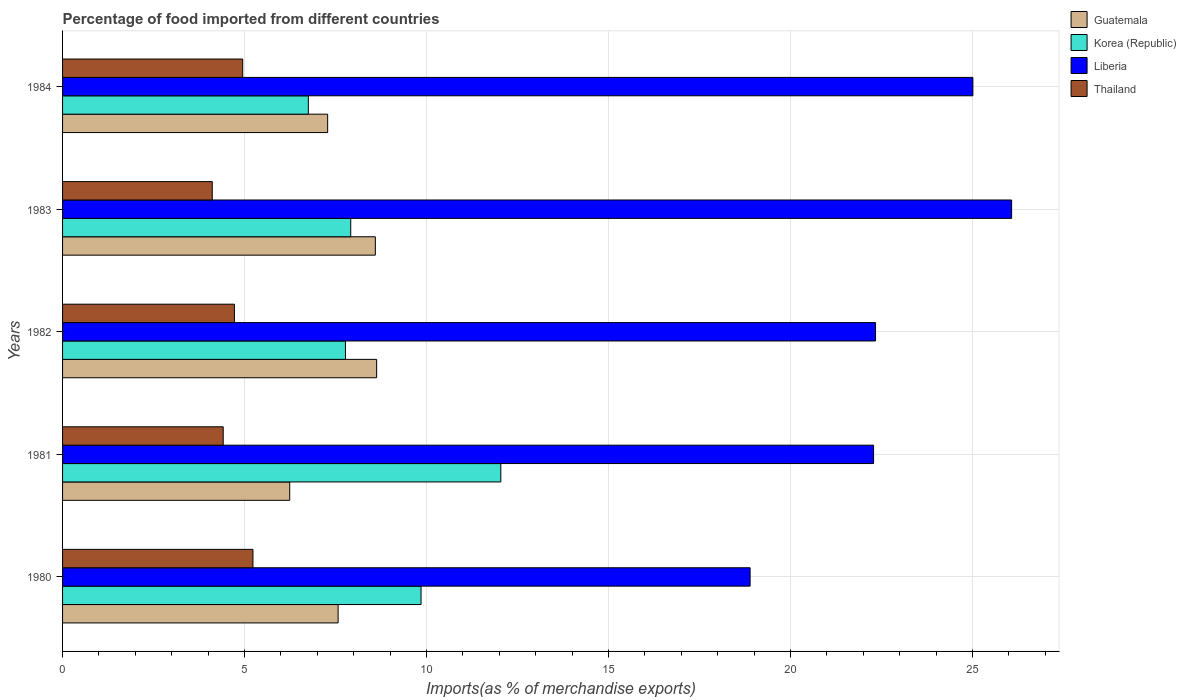How many different coloured bars are there?
Your answer should be compact. 4. Are the number of bars per tick equal to the number of legend labels?
Make the answer very short. Yes. Are the number of bars on each tick of the Y-axis equal?
Provide a succinct answer. Yes. In how many cases, is the number of bars for a given year not equal to the number of legend labels?
Your answer should be very brief. 0. What is the percentage of imports to different countries in Korea (Republic) in 1982?
Your answer should be very brief. 7.77. Across all years, what is the maximum percentage of imports to different countries in Guatemala?
Provide a succinct answer. 8.63. Across all years, what is the minimum percentage of imports to different countries in Guatemala?
Offer a very short reply. 6.24. In which year was the percentage of imports to different countries in Guatemala maximum?
Offer a terse response. 1982. In which year was the percentage of imports to different countries in Liberia minimum?
Give a very brief answer. 1980. What is the total percentage of imports to different countries in Korea (Republic) in the graph?
Keep it short and to the point. 44.33. What is the difference between the percentage of imports to different countries in Thailand in 1980 and that in 1984?
Your response must be concise. 0.28. What is the difference between the percentage of imports to different countries in Liberia in 1980 and the percentage of imports to different countries in Korea (Republic) in 1982?
Ensure brevity in your answer.  11.12. What is the average percentage of imports to different countries in Korea (Republic) per year?
Offer a terse response. 8.87. In the year 1981, what is the difference between the percentage of imports to different countries in Guatemala and percentage of imports to different countries in Liberia?
Your response must be concise. -16.04. In how many years, is the percentage of imports to different countries in Liberia greater than 11 %?
Offer a very short reply. 5. What is the ratio of the percentage of imports to different countries in Korea (Republic) in 1981 to that in 1983?
Provide a short and direct response. 1.52. Is the difference between the percentage of imports to different countries in Guatemala in 1983 and 1984 greater than the difference between the percentage of imports to different countries in Liberia in 1983 and 1984?
Give a very brief answer. Yes. What is the difference between the highest and the second highest percentage of imports to different countries in Guatemala?
Provide a succinct answer. 0.04. What is the difference between the highest and the lowest percentage of imports to different countries in Korea (Republic)?
Give a very brief answer. 5.29. In how many years, is the percentage of imports to different countries in Guatemala greater than the average percentage of imports to different countries in Guatemala taken over all years?
Your answer should be compact. 2. Is the sum of the percentage of imports to different countries in Liberia in 1980 and 1983 greater than the maximum percentage of imports to different countries in Thailand across all years?
Make the answer very short. Yes. What does the 4th bar from the top in 1980 represents?
Offer a terse response. Guatemala. What does the 2nd bar from the bottom in 1981 represents?
Your answer should be compact. Korea (Republic). Is it the case that in every year, the sum of the percentage of imports to different countries in Korea (Republic) and percentage of imports to different countries in Guatemala is greater than the percentage of imports to different countries in Liberia?
Provide a succinct answer. No. How many bars are there?
Ensure brevity in your answer.  20. How many years are there in the graph?
Provide a short and direct response. 5. Does the graph contain any zero values?
Provide a succinct answer. No. Does the graph contain grids?
Offer a very short reply. Yes. How many legend labels are there?
Provide a short and direct response. 4. What is the title of the graph?
Ensure brevity in your answer.  Percentage of food imported from different countries. What is the label or title of the X-axis?
Keep it short and to the point. Imports(as % of merchandise exports). What is the Imports(as % of merchandise exports) in Guatemala in 1980?
Provide a succinct answer. 7.57. What is the Imports(as % of merchandise exports) of Korea (Republic) in 1980?
Give a very brief answer. 9.85. What is the Imports(as % of merchandise exports) of Liberia in 1980?
Offer a very short reply. 18.89. What is the Imports(as % of merchandise exports) in Thailand in 1980?
Your response must be concise. 5.23. What is the Imports(as % of merchandise exports) of Guatemala in 1981?
Provide a succinct answer. 6.24. What is the Imports(as % of merchandise exports) in Korea (Republic) in 1981?
Offer a very short reply. 12.04. What is the Imports(as % of merchandise exports) of Liberia in 1981?
Make the answer very short. 22.28. What is the Imports(as % of merchandise exports) in Thailand in 1981?
Offer a terse response. 4.41. What is the Imports(as % of merchandise exports) in Guatemala in 1982?
Make the answer very short. 8.63. What is the Imports(as % of merchandise exports) in Korea (Republic) in 1982?
Provide a short and direct response. 7.77. What is the Imports(as % of merchandise exports) of Liberia in 1982?
Ensure brevity in your answer.  22.34. What is the Imports(as % of merchandise exports) of Thailand in 1982?
Provide a succinct answer. 4.72. What is the Imports(as % of merchandise exports) of Guatemala in 1983?
Provide a succinct answer. 8.59. What is the Imports(as % of merchandise exports) of Korea (Republic) in 1983?
Your answer should be compact. 7.92. What is the Imports(as % of merchandise exports) of Liberia in 1983?
Your answer should be compact. 26.08. What is the Imports(as % of merchandise exports) in Thailand in 1983?
Provide a succinct answer. 4.11. What is the Imports(as % of merchandise exports) of Guatemala in 1984?
Ensure brevity in your answer.  7.28. What is the Imports(as % of merchandise exports) in Korea (Republic) in 1984?
Give a very brief answer. 6.75. What is the Imports(as % of merchandise exports) in Liberia in 1984?
Give a very brief answer. 25.01. What is the Imports(as % of merchandise exports) of Thailand in 1984?
Your answer should be compact. 4.95. Across all years, what is the maximum Imports(as % of merchandise exports) of Guatemala?
Your answer should be compact. 8.63. Across all years, what is the maximum Imports(as % of merchandise exports) in Korea (Republic)?
Provide a succinct answer. 12.04. Across all years, what is the maximum Imports(as % of merchandise exports) in Liberia?
Give a very brief answer. 26.08. Across all years, what is the maximum Imports(as % of merchandise exports) in Thailand?
Give a very brief answer. 5.23. Across all years, what is the minimum Imports(as % of merchandise exports) in Guatemala?
Your response must be concise. 6.24. Across all years, what is the minimum Imports(as % of merchandise exports) in Korea (Republic)?
Your answer should be compact. 6.75. Across all years, what is the minimum Imports(as % of merchandise exports) of Liberia?
Ensure brevity in your answer.  18.89. Across all years, what is the minimum Imports(as % of merchandise exports) in Thailand?
Your answer should be very brief. 4.11. What is the total Imports(as % of merchandise exports) of Guatemala in the graph?
Give a very brief answer. 38.32. What is the total Imports(as % of merchandise exports) of Korea (Republic) in the graph?
Keep it short and to the point. 44.33. What is the total Imports(as % of merchandise exports) of Liberia in the graph?
Keep it short and to the point. 114.6. What is the total Imports(as % of merchandise exports) of Thailand in the graph?
Give a very brief answer. 23.43. What is the difference between the Imports(as % of merchandise exports) of Guatemala in 1980 and that in 1981?
Provide a succinct answer. 1.33. What is the difference between the Imports(as % of merchandise exports) of Korea (Republic) in 1980 and that in 1981?
Provide a short and direct response. -2.19. What is the difference between the Imports(as % of merchandise exports) of Liberia in 1980 and that in 1981?
Offer a terse response. -3.39. What is the difference between the Imports(as % of merchandise exports) in Thailand in 1980 and that in 1981?
Your response must be concise. 0.82. What is the difference between the Imports(as % of merchandise exports) in Guatemala in 1980 and that in 1982?
Offer a very short reply. -1.06. What is the difference between the Imports(as % of merchandise exports) of Korea (Republic) in 1980 and that in 1982?
Offer a terse response. 2.08. What is the difference between the Imports(as % of merchandise exports) of Liberia in 1980 and that in 1982?
Provide a short and direct response. -3.45. What is the difference between the Imports(as % of merchandise exports) in Thailand in 1980 and that in 1982?
Ensure brevity in your answer.  0.51. What is the difference between the Imports(as % of merchandise exports) in Guatemala in 1980 and that in 1983?
Your response must be concise. -1.02. What is the difference between the Imports(as % of merchandise exports) of Korea (Republic) in 1980 and that in 1983?
Your answer should be very brief. 1.93. What is the difference between the Imports(as % of merchandise exports) in Liberia in 1980 and that in 1983?
Make the answer very short. -7.19. What is the difference between the Imports(as % of merchandise exports) of Thailand in 1980 and that in 1983?
Your answer should be compact. 1.12. What is the difference between the Imports(as % of merchandise exports) of Guatemala in 1980 and that in 1984?
Keep it short and to the point. 0.29. What is the difference between the Imports(as % of merchandise exports) in Korea (Republic) in 1980 and that in 1984?
Provide a succinct answer. 3.1. What is the difference between the Imports(as % of merchandise exports) in Liberia in 1980 and that in 1984?
Offer a terse response. -6.12. What is the difference between the Imports(as % of merchandise exports) in Thailand in 1980 and that in 1984?
Keep it short and to the point. 0.28. What is the difference between the Imports(as % of merchandise exports) in Guatemala in 1981 and that in 1982?
Your answer should be very brief. -2.39. What is the difference between the Imports(as % of merchandise exports) in Korea (Republic) in 1981 and that in 1982?
Your answer should be compact. 4.27. What is the difference between the Imports(as % of merchandise exports) in Liberia in 1981 and that in 1982?
Provide a short and direct response. -0.05. What is the difference between the Imports(as % of merchandise exports) in Thailand in 1981 and that in 1982?
Provide a succinct answer. -0.31. What is the difference between the Imports(as % of merchandise exports) in Guatemala in 1981 and that in 1983?
Keep it short and to the point. -2.35. What is the difference between the Imports(as % of merchandise exports) of Korea (Republic) in 1981 and that in 1983?
Keep it short and to the point. 4.12. What is the difference between the Imports(as % of merchandise exports) in Liberia in 1981 and that in 1983?
Provide a short and direct response. -3.79. What is the difference between the Imports(as % of merchandise exports) in Thailand in 1981 and that in 1983?
Your response must be concise. 0.3. What is the difference between the Imports(as % of merchandise exports) in Guatemala in 1981 and that in 1984?
Ensure brevity in your answer.  -1.04. What is the difference between the Imports(as % of merchandise exports) in Korea (Republic) in 1981 and that in 1984?
Your response must be concise. 5.29. What is the difference between the Imports(as % of merchandise exports) of Liberia in 1981 and that in 1984?
Your answer should be compact. -2.73. What is the difference between the Imports(as % of merchandise exports) of Thailand in 1981 and that in 1984?
Give a very brief answer. -0.54. What is the difference between the Imports(as % of merchandise exports) in Guatemala in 1982 and that in 1983?
Make the answer very short. 0.04. What is the difference between the Imports(as % of merchandise exports) of Korea (Republic) in 1982 and that in 1983?
Keep it short and to the point. -0.15. What is the difference between the Imports(as % of merchandise exports) of Liberia in 1982 and that in 1983?
Offer a terse response. -3.74. What is the difference between the Imports(as % of merchandise exports) of Thailand in 1982 and that in 1983?
Provide a succinct answer. 0.61. What is the difference between the Imports(as % of merchandise exports) in Guatemala in 1982 and that in 1984?
Make the answer very short. 1.35. What is the difference between the Imports(as % of merchandise exports) of Korea (Republic) in 1982 and that in 1984?
Your answer should be very brief. 1.02. What is the difference between the Imports(as % of merchandise exports) in Liberia in 1982 and that in 1984?
Make the answer very short. -2.68. What is the difference between the Imports(as % of merchandise exports) of Thailand in 1982 and that in 1984?
Provide a short and direct response. -0.23. What is the difference between the Imports(as % of merchandise exports) in Guatemala in 1983 and that in 1984?
Your answer should be very brief. 1.31. What is the difference between the Imports(as % of merchandise exports) in Korea (Republic) in 1983 and that in 1984?
Your answer should be compact. 1.17. What is the difference between the Imports(as % of merchandise exports) in Liberia in 1983 and that in 1984?
Offer a terse response. 1.06. What is the difference between the Imports(as % of merchandise exports) of Thailand in 1983 and that in 1984?
Provide a short and direct response. -0.84. What is the difference between the Imports(as % of merchandise exports) in Guatemala in 1980 and the Imports(as % of merchandise exports) in Korea (Republic) in 1981?
Provide a short and direct response. -4.47. What is the difference between the Imports(as % of merchandise exports) of Guatemala in 1980 and the Imports(as % of merchandise exports) of Liberia in 1981?
Offer a terse response. -14.71. What is the difference between the Imports(as % of merchandise exports) of Guatemala in 1980 and the Imports(as % of merchandise exports) of Thailand in 1981?
Offer a very short reply. 3.16. What is the difference between the Imports(as % of merchandise exports) of Korea (Republic) in 1980 and the Imports(as % of merchandise exports) of Liberia in 1981?
Offer a very short reply. -12.43. What is the difference between the Imports(as % of merchandise exports) in Korea (Republic) in 1980 and the Imports(as % of merchandise exports) in Thailand in 1981?
Offer a terse response. 5.44. What is the difference between the Imports(as % of merchandise exports) in Liberia in 1980 and the Imports(as % of merchandise exports) in Thailand in 1981?
Your response must be concise. 14.48. What is the difference between the Imports(as % of merchandise exports) in Guatemala in 1980 and the Imports(as % of merchandise exports) in Korea (Republic) in 1982?
Keep it short and to the point. -0.2. What is the difference between the Imports(as % of merchandise exports) of Guatemala in 1980 and the Imports(as % of merchandise exports) of Liberia in 1982?
Keep it short and to the point. -14.77. What is the difference between the Imports(as % of merchandise exports) in Guatemala in 1980 and the Imports(as % of merchandise exports) in Thailand in 1982?
Provide a succinct answer. 2.85. What is the difference between the Imports(as % of merchandise exports) of Korea (Republic) in 1980 and the Imports(as % of merchandise exports) of Liberia in 1982?
Your answer should be very brief. -12.49. What is the difference between the Imports(as % of merchandise exports) in Korea (Republic) in 1980 and the Imports(as % of merchandise exports) in Thailand in 1982?
Offer a very short reply. 5.13. What is the difference between the Imports(as % of merchandise exports) of Liberia in 1980 and the Imports(as % of merchandise exports) of Thailand in 1982?
Provide a succinct answer. 14.17. What is the difference between the Imports(as % of merchandise exports) in Guatemala in 1980 and the Imports(as % of merchandise exports) in Korea (Republic) in 1983?
Your response must be concise. -0.35. What is the difference between the Imports(as % of merchandise exports) of Guatemala in 1980 and the Imports(as % of merchandise exports) of Liberia in 1983?
Offer a very short reply. -18.5. What is the difference between the Imports(as % of merchandise exports) of Guatemala in 1980 and the Imports(as % of merchandise exports) of Thailand in 1983?
Provide a short and direct response. 3.46. What is the difference between the Imports(as % of merchandise exports) in Korea (Republic) in 1980 and the Imports(as % of merchandise exports) in Liberia in 1983?
Give a very brief answer. -16.23. What is the difference between the Imports(as % of merchandise exports) in Korea (Republic) in 1980 and the Imports(as % of merchandise exports) in Thailand in 1983?
Keep it short and to the point. 5.74. What is the difference between the Imports(as % of merchandise exports) in Liberia in 1980 and the Imports(as % of merchandise exports) in Thailand in 1983?
Offer a terse response. 14.78. What is the difference between the Imports(as % of merchandise exports) in Guatemala in 1980 and the Imports(as % of merchandise exports) in Korea (Republic) in 1984?
Make the answer very short. 0.82. What is the difference between the Imports(as % of merchandise exports) of Guatemala in 1980 and the Imports(as % of merchandise exports) of Liberia in 1984?
Your response must be concise. -17.44. What is the difference between the Imports(as % of merchandise exports) in Guatemala in 1980 and the Imports(as % of merchandise exports) in Thailand in 1984?
Make the answer very short. 2.62. What is the difference between the Imports(as % of merchandise exports) of Korea (Republic) in 1980 and the Imports(as % of merchandise exports) of Liberia in 1984?
Offer a terse response. -15.16. What is the difference between the Imports(as % of merchandise exports) of Korea (Republic) in 1980 and the Imports(as % of merchandise exports) of Thailand in 1984?
Your answer should be compact. 4.9. What is the difference between the Imports(as % of merchandise exports) in Liberia in 1980 and the Imports(as % of merchandise exports) in Thailand in 1984?
Offer a terse response. 13.94. What is the difference between the Imports(as % of merchandise exports) in Guatemala in 1981 and the Imports(as % of merchandise exports) in Korea (Republic) in 1982?
Give a very brief answer. -1.53. What is the difference between the Imports(as % of merchandise exports) in Guatemala in 1981 and the Imports(as % of merchandise exports) in Liberia in 1982?
Your response must be concise. -16.1. What is the difference between the Imports(as % of merchandise exports) of Guatemala in 1981 and the Imports(as % of merchandise exports) of Thailand in 1982?
Ensure brevity in your answer.  1.52. What is the difference between the Imports(as % of merchandise exports) of Korea (Republic) in 1981 and the Imports(as % of merchandise exports) of Liberia in 1982?
Ensure brevity in your answer.  -10.3. What is the difference between the Imports(as % of merchandise exports) of Korea (Republic) in 1981 and the Imports(as % of merchandise exports) of Thailand in 1982?
Your answer should be very brief. 7.32. What is the difference between the Imports(as % of merchandise exports) in Liberia in 1981 and the Imports(as % of merchandise exports) in Thailand in 1982?
Keep it short and to the point. 17.56. What is the difference between the Imports(as % of merchandise exports) in Guatemala in 1981 and the Imports(as % of merchandise exports) in Korea (Republic) in 1983?
Provide a succinct answer. -1.68. What is the difference between the Imports(as % of merchandise exports) of Guatemala in 1981 and the Imports(as % of merchandise exports) of Liberia in 1983?
Your answer should be very brief. -19.83. What is the difference between the Imports(as % of merchandise exports) of Guatemala in 1981 and the Imports(as % of merchandise exports) of Thailand in 1983?
Keep it short and to the point. 2.13. What is the difference between the Imports(as % of merchandise exports) in Korea (Republic) in 1981 and the Imports(as % of merchandise exports) in Liberia in 1983?
Your answer should be compact. -14.03. What is the difference between the Imports(as % of merchandise exports) in Korea (Republic) in 1981 and the Imports(as % of merchandise exports) in Thailand in 1983?
Your answer should be very brief. 7.93. What is the difference between the Imports(as % of merchandise exports) of Liberia in 1981 and the Imports(as % of merchandise exports) of Thailand in 1983?
Ensure brevity in your answer.  18.17. What is the difference between the Imports(as % of merchandise exports) in Guatemala in 1981 and the Imports(as % of merchandise exports) in Korea (Republic) in 1984?
Make the answer very short. -0.51. What is the difference between the Imports(as % of merchandise exports) of Guatemala in 1981 and the Imports(as % of merchandise exports) of Liberia in 1984?
Provide a short and direct response. -18.77. What is the difference between the Imports(as % of merchandise exports) of Guatemala in 1981 and the Imports(as % of merchandise exports) of Thailand in 1984?
Keep it short and to the point. 1.29. What is the difference between the Imports(as % of merchandise exports) of Korea (Republic) in 1981 and the Imports(as % of merchandise exports) of Liberia in 1984?
Ensure brevity in your answer.  -12.97. What is the difference between the Imports(as % of merchandise exports) in Korea (Republic) in 1981 and the Imports(as % of merchandise exports) in Thailand in 1984?
Your answer should be very brief. 7.09. What is the difference between the Imports(as % of merchandise exports) in Liberia in 1981 and the Imports(as % of merchandise exports) in Thailand in 1984?
Keep it short and to the point. 17.33. What is the difference between the Imports(as % of merchandise exports) in Guatemala in 1982 and the Imports(as % of merchandise exports) in Korea (Republic) in 1983?
Provide a succinct answer. 0.71. What is the difference between the Imports(as % of merchandise exports) in Guatemala in 1982 and the Imports(as % of merchandise exports) in Liberia in 1983?
Ensure brevity in your answer.  -17.45. What is the difference between the Imports(as % of merchandise exports) of Guatemala in 1982 and the Imports(as % of merchandise exports) of Thailand in 1983?
Provide a short and direct response. 4.52. What is the difference between the Imports(as % of merchandise exports) in Korea (Republic) in 1982 and the Imports(as % of merchandise exports) in Liberia in 1983?
Make the answer very short. -18.3. What is the difference between the Imports(as % of merchandise exports) of Korea (Republic) in 1982 and the Imports(as % of merchandise exports) of Thailand in 1983?
Offer a very short reply. 3.66. What is the difference between the Imports(as % of merchandise exports) of Liberia in 1982 and the Imports(as % of merchandise exports) of Thailand in 1983?
Your response must be concise. 18.22. What is the difference between the Imports(as % of merchandise exports) of Guatemala in 1982 and the Imports(as % of merchandise exports) of Korea (Republic) in 1984?
Provide a short and direct response. 1.88. What is the difference between the Imports(as % of merchandise exports) of Guatemala in 1982 and the Imports(as % of merchandise exports) of Liberia in 1984?
Provide a short and direct response. -16.38. What is the difference between the Imports(as % of merchandise exports) in Guatemala in 1982 and the Imports(as % of merchandise exports) in Thailand in 1984?
Your response must be concise. 3.68. What is the difference between the Imports(as % of merchandise exports) of Korea (Republic) in 1982 and the Imports(as % of merchandise exports) of Liberia in 1984?
Provide a succinct answer. -17.24. What is the difference between the Imports(as % of merchandise exports) in Korea (Republic) in 1982 and the Imports(as % of merchandise exports) in Thailand in 1984?
Keep it short and to the point. 2.82. What is the difference between the Imports(as % of merchandise exports) in Liberia in 1982 and the Imports(as % of merchandise exports) in Thailand in 1984?
Your answer should be compact. 17.39. What is the difference between the Imports(as % of merchandise exports) in Guatemala in 1983 and the Imports(as % of merchandise exports) in Korea (Republic) in 1984?
Provide a short and direct response. 1.84. What is the difference between the Imports(as % of merchandise exports) of Guatemala in 1983 and the Imports(as % of merchandise exports) of Liberia in 1984?
Offer a very short reply. -16.42. What is the difference between the Imports(as % of merchandise exports) in Guatemala in 1983 and the Imports(as % of merchandise exports) in Thailand in 1984?
Provide a short and direct response. 3.64. What is the difference between the Imports(as % of merchandise exports) of Korea (Republic) in 1983 and the Imports(as % of merchandise exports) of Liberia in 1984?
Provide a succinct answer. -17.09. What is the difference between the Imports(as % of merchandise exports) of Korea (Republic) in 1983 and the Imports(as % of merchandise exports) of Thailand in 1984?
Your response must be concise. 2.97. What is the difference between the Imports(as % of merchandise exports) in Liberia in 1983 and the Imports(as % of merchandise exports) in Thailand in 1984?
Keep it short and to the point. 21.13. What is the average Imports(as % of merchandise exports) of Guatemala per year?
Make the answer very short. 7.66. What is the average Imports(as % of merchandise exports) of Korea (Republic) per year?
Offer a very short reply. 8.87. What is the average Imports(as % of merchandise exports) in Liberia per year?
Your answer should be very brief. 22.92. What is the average Imports(as % of merchandise exports) of Thailand per year?
Ensure brevity in your answer.  4.69. In the year 1980, what is the difference between the Imports(as % of merchandise exports) of Guatemala and Imports(as % of merchandise exports) of Korea (Republic)?
Provide a succinct answer. -2.28. In the year 1980, what is the difference between the Imports(as % of merchandise exports) in Guatemala and Imports(as % of merchandise exports) in Liberia?
Ensure brevity in your answer.  -11.32. In the year 1980, what is the difference between the Imports(as % of merchandise exports) in Guatemala and Imports(as % of merchandise exports) in Thailand?
Ensure brevity in your answer.  2.34. In the year 1980, what is the difference between the Imports(as % of merchandise exports) of Korea (Republic) and Imports(as % of merchandise exports) of Liberia?
Your answer should be very brief. -9.04. In the year 1980, what is the difference between the Imports(as % of merchandise exports) in Korea (Republic) and Imports(as % of merchandise exports) in Thailand?
Keep it short and to the point. 4.62. In the year 1980, what is the difference between the Imports(as % of merchandise exports) of Liberia and Imports(as % of merchandise exports) of Thailand?
Offer a terse response. 13.66. In the year 1981, what is the difference between the Imports(as % of merchandise exports) of Guatemala and Imports(as % of merchandise exports) of Korea (Republic)?
Provide a short and direct response. -5.8. In the year 1981, what is the difference between the Imports(as % of merchandise exports) of Guatemala and Imports(as % of merchandise exports) of Liberia?
Ensure brevity in your answer.  -16.04. In the year 1981, what is the difference between the Imports(as % of merchandise exports) of Guatemala and Imports(as % of merchandise exports) of Thailand?
Give a very brief answer. 1.83. In the year 1981, what is the difference between the Imports(as % of merchandise exports) of Korea (Republic) and Imports(as % of merchandise exports) of Liberia?
Ensure brevity in your answer.  -10.24. In the year 1981, what is the difference between the Imports(as % of merchandise exports) in Korea (Republic) and Imports(as % of merchandise exports) in Thailand?
Your answer should be compact. 7.63. In the year 1981, what is the difference between the Imports(as % of merchandise exports) of Liberia and Imports(as % of merchandise exports) of Thailand?
Your answer should be compact. 17.87. In the year 1982, what is the difference between the Imports(as % of merchandise exports) of Guatemala and Imports(as % of merchandise exports) of Korea (Republic)?
Keep it short and to the point. 0.86. In the year 1982, what is the difference between the Imports(as % of merchandise exports) in Guatemala and Imports(as % of merchandise exports) in Liberia?
Make the answer very short. -13.71. In the year 1982, what is the difference between the Imports(as % of merchandise exports) in Guatemala and Imports(as % of merchandise exports) in Thailand?
Your response must be concise. 3.91. In the year 1982, what is the difference between the Imports(as % of merchandise exports) of Korea (Republic) and Imports(as % of merchandise exports) of Liberia?
Offer a terse response. -14.56. In the year 1982, what is the difference between the Imports(as % of merchandise exports) in Korea (Republic) and Imports(as % of merchandise exports) in Thailand?
Offer a terse response. 3.05. In the year 1982, what is the difference between the Imports(as % of merchandise exports) in Liberia and Imports(as % of merchandise exports) in Thailand?
Provide a succinct answer. 17.61. In the year 1983, what is the difference between the Imports(as % of merchandise exports) of Guatemala and Imports(as % of merchandise exports) of Korea (Republic)?
Your answer should be very brief. 0.68. In the year 1983, what is the difference between the Imports(as % of merchandise exports) in Guatemala and Imports(as % of merchandise exports) in Liberia?
Provide a short and direct response. -17.48. In the year 1983, what is the difference between the Imports(as % of merchandise exports) of Guatemala and Imports(as % of merchandise exports) of Thailand?
Your answer should be compact. 4.48. In the year 1983, what is the difference between the Imports(as % of merchandise exports) in Korea (Republic) and Imports(as % of merchandise exports) in Liberia?
Make the answer very short. -18.16. In the year 1983, what is the difference between the Imports(as % of merchandise exports) of Korea (Republic) and Imports(as % of merchandise exports) of Thailand?
Offer a very short reply. 3.8. In the year 1983, what is the difference between the Imports(as % of merchandise exports) of Liberia and Imports(as % of merchandise exports) of Thailand?
Your response must be concise. 21.96. In the year 1984, what is the difference between the Imports(as % of merchandise exports) in Guatemala and Imports(as % of merchandise exports) in Korea (Republic)?
Your response must be concise. 0.53. In the year 1984, what is the difference between the Imports(as % of merchandise exports) in Guatemala and Imports(as % of merchandise exports) in Liberia?
Offer a very short reply. -17.73. In the year 1984, what is the difference between the Imports(as % of merchandise exports) of Guatemala and Imports(as % of merchandise exports) of Thailand?
Offer a very short reply. 2.33. In the year 1984, what is the difference between the Imports(as % of merchandise exports) in Korea (Republic) and Imports(as % of merchandise exports) in Liberia?
Offer a very short reply. -18.26. In the year 1984, what is the difference between the Imports(as % of merchandise exports) of Korea (Republic) and Imports(as % of merchandise exports) of Thailand?
Provide a short and direct response. 1.8. In the year 1984, what is the difference between the Imports(as % of merchandise exports) of Liberia and Imports(as % of merchandise exports) of Thailand?
Ensure brevity in your answer.  20.06. What is the ratio of the Imports(as % of merchandise exports) in Guatemala in 1980 to that in 1981?
Provide a short and direct response. 1.21. What is the ratio of the Imports(as % of merchandise exports) in Korea (Republic) in 1980 to that in 1981?
Make the answer very short. 0.82. What is the ratio of the Imports(as % of merchandise exports) in Liberia in 1980 to that in 1981?
Keep it short and to the point. 0.85. What is the ratio of the Imports(as % of merchandise exports) in Thailand in 1980 to that in 1981?
Your answer should be very brief. 1.19. What is the ratio of the Imports(as % of merchandise exports) in Guatemala in 1980 to that in 1982?
Your response must be concise. 0.88. What is the ratio of the Imports(as % of merchandise exports) in Korea (Republic) in 1980 to that in 1982?
Offer a terse response. 1.27. What is the ratio of the Imports(as % of merchandise exports) in Liberia in 1980 to that in 1982?
Offer a very short reply. 0.85. What is the ratio of the Imports(as % of merchandise exports) of Thailand in 1980 to that in 1982?
Make the answer very short. 1.11. What is the ratio of the Imports(as % of merchandise exports) of Guatemala in 1980 to that in 1983?
Provide a short and direct response. 0.88. What is the ratio of the Imports(as % of merchandise exports) in Korea (Republic) in 1980 to that in 1983?
Offer a very short reply. 1.24. What is the ratio of the Imports(as % of merchandise exports) of Liberia in 1980 to that in 1983?
Ensure brevity in your answer.  0.72. What is the ratio of the Imports(as % of merchandise exports) in Thailand in 1980 to that in 1983?
Your response must be concise. 1.27. What is the ratio of the Imports(as % of merchandise exports) of Guatemala in 1980 to that in 1984?
Your answer should be very brief. 1.04. What is the ratio of the Imports(as % of merchandise exports) of Korea (Republic) in 1980 to that in 1984?
Make the answer very short. 1.46. What is the ratio of the Imports(as % of merchandise exports) in Liberia in 1980 to that in 1984?
Keep it short and to the point. 0.76. What is the ratio of the Imports(as % of merchandise exports) in Thailand in 1980 to that in 1984?
Your answer should be very brief. 1.06. What is the ratio of the Imports(as % of merchandise exports) of Guatemala in 1981 to that in 1982?
Your answer should be compact. 0.72. What is the ratio of the Imports(as % of merchandise exports) of Korea (Republic) in 1981 to that in 1982?
Keep it short and to the point. 1.55. What is the ratio of the Imports(as % of merchandise exports) of Liberia in 1981 to that in 1982?
Your response must be concise. 1. What is the ratio of the Imports(as % of merchandise exports) in Thailand in 1981 to that in 1982?
Make the answer very short. 0.93. What is the ratio of the Imports(as % of merchandise exports) of Guatemala in 1981 to that in 1983?
Your answer should be very brief. 0.73. What is the ratio of the Imports(as % of merchandise exports) of Korea (Republic) in 1981 to that in 1983?
Offer a very short reply. 1.52. What is the ratio of the Imports(as % of merchandise exports) of Liberia in 1981 to that in 1983?
Keep it short and to the point. 0.85. What is the ratio of the Imports(as % of merchandise exports) of Thailand in 1981 to that in 1983?
Your answer should be compact. 1.07. What is the ratio of the Imports(as % of merchandise exports) of Guatemala in 1981 to that in 1984?
Offer a very short reply. 0.86. What is the ratio of the Imports(as % of merchandise exports) in Korea (Republic) in 1981 to that in 1984?
Keep it short and to the point. 1.78. What is the ratio of the Imports(as % of merchandise exports) in Liberia in 1981 to that in 1984?
Make the answer very short. 0.89. What is the ratio of the Imports(as % of merchandise exports) in Thailand in 1981 to that in 1984?
Make the answer very short. 0.89. What is the ratio of the Imports(as % of merchandise exports) of Korea (Republic) in 1982 to that in 1983?
Make the answer very short. 0.98. What is the ratio of the Imports(as % of merchandise exports) of Liberia in 1982 to that in 1983?
Your answer should be very brief. 0.86. What is the ratio of the Imports(as % of merchandise exports) of Thailand in 1982 to that in 1983?
Your response must be concise. 1.15. What is the ratio of the Imports(as % of merchandise exports) in Guatemala in 1982 to that in 1984?
Offer a very short reply. 1.18. What is the ratio of the Imports(as % of merchandise exports) of Korea (Republic) in 1982 to that in 1984?
Offer a terse response. 1.15. What is the ratio of the Imports(as % of merchandise exports) of Liberia in 1982 to that in 1984?
Your answer should be very brief. 0.89. What is the ratio of the Imports(as % of merchandise exports) in Thailand in 1982 to that in 1984?
Offer a terse response. 0.95. What is the ratio of the Imports(as % of merchandise exports) of Guatemala in 1983 to that in 1984?
Your response must be concise. 1.18. What is the ratio of the Imports(as % of merchandise exports) of Korea (Republic) in 1983 to that in 1984?
Offer a very short reply. 1.17. What is the ratio of the Imports(as % of merchandise exports) of Liberia in 1983 to that in 1984?
Give a very brief answer. 1.04. What is the ratio of the Imports(as % of merchandise exports) in Thailand in 1983 to that in 1984?
Provide a short and direct response. 0.83. What is the difference between the highest and the second highest Imports(as % of merchandise exports) of Guatemala?
Your answer should be very brief. 0.04. What is the difference between the highest and the second highest Imports(as % of merchandise exports) of Korea (Republic)?
Give a very brief answer. 2.19. What is the difference between the highest and the second highest Imports(as % of merchandise exports) of Liberia?
Ensure brevity in your answer.  1.06. What is the difference between the highest and the second highest Imports(as % of merchandise exports) of Thailand?
Provide a succinct answer. 0.28. What is the difference between the highest and the lowest Imports(as % of merchandise exports) in Guatemala?
Offer a terse response. 2.39. What is the difference between the highest and the lowest Imports(as % of merchandise exports) in Korea (Republic)?
Your response must be concise. 5.29. What is the difference between the highest and the lowest Imports(as % of merchandise exports) in Liberia?
Your response must be concise. 7.19. What is the difference between the highest and the lowest Imports(as % of merchandise exports) in Thailand?
Keep it short and to the point. 1.12. 